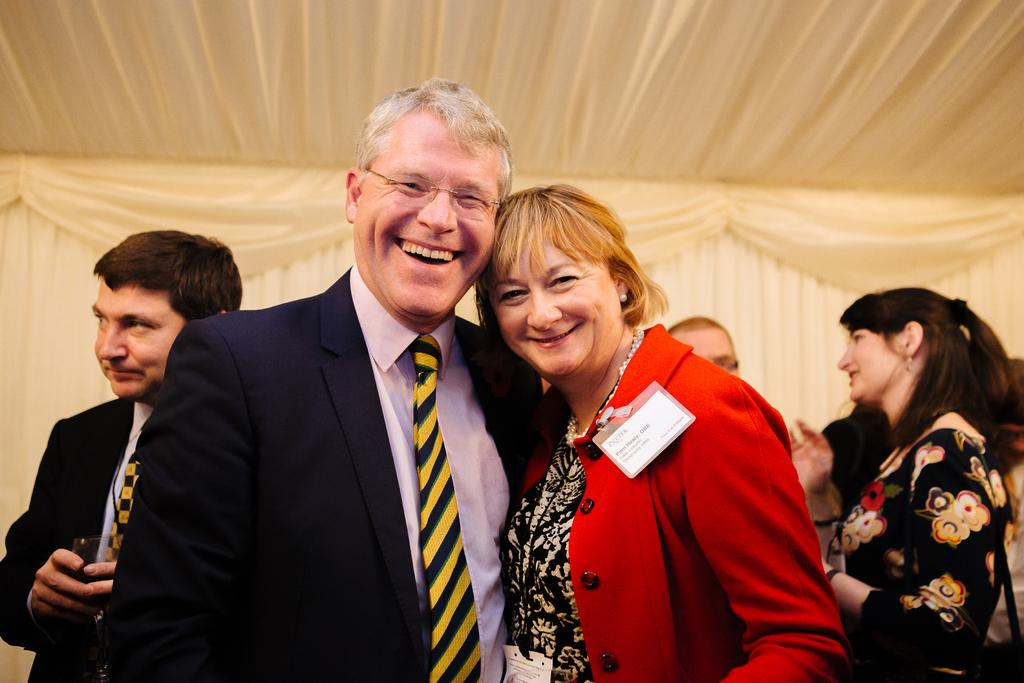What are the two people in the image doing? The two people in the image are posing for a picture. Can you describe the people standing behind them? There is a group of people standing behind the two people who are posing for a picture. What type of scent can be smelled coming from the leg of the person on the left? There is no mention of a scent or a leg in the image, so it is not possible to determine what scent might be present. 